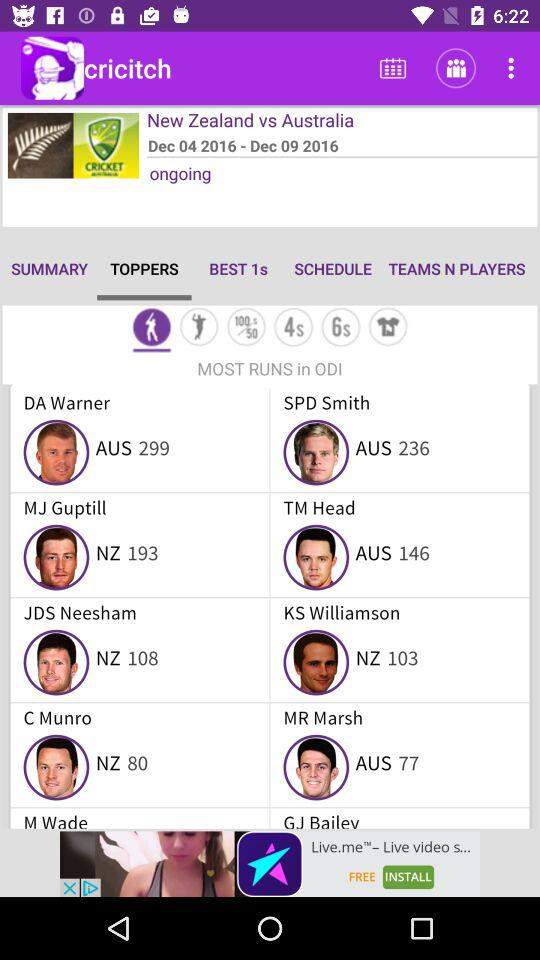How long the match played?
When the provided information is insufficient, respond with <no answer>. <no answer> 